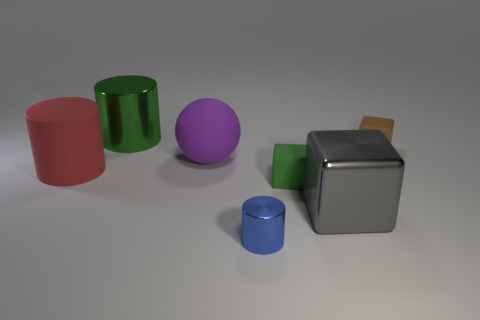What color is the large metal thing on the right side of the large rubber ball?
Make the answer very short. Gray. There is a object that is in front of the cube that is in front of the small cube in front of the big sphere; what is it made of?
Keep it short and to the point. Metal. There is a object behind the matte cube that is behind the tiny green object; what size is it?
Your answer should be very brief. Large. What is the color of the shiny object that is the same shape as the tiny brown matte thing?
Keep it short and to the point. Gray. How many rubber things are the same color as the matte ball?
Make the answer very short. 0. Do the blue cylinder and the green cube have the same size?
Your answer should be very brief. Yes. What is the material of the purple thing?
Offer a very short reply. Rubber. What is the color of the big thing that is the same material as the red cylinder?
Your answer should be compact. Purple. Does the green cylinder have the same material as the small thing that is in front of the big gray metal object?
Offer a very short reply. Yes. How many small blue cylinders are the same material as the large gray block?
Keep it short and to the point. 1. 